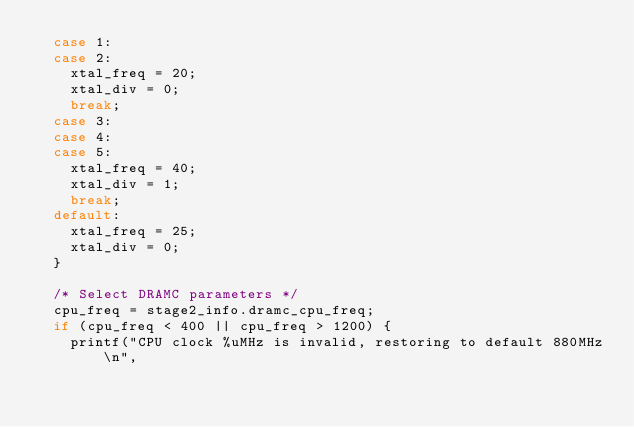<code> <loc_0><loc_0><loc_500><loc_500><_C_>	case 1:
	case 2:
		xtal_freq = 20;
		xtal_div = 0;
		break;
	case 3:
	case 4:
	case 5:
		xtal_freq = 40;
		xtal_div = 1;
		break;
	default:
		xtal_freq = 25;
		xtal_div = 0;
	}

	/* Select DRAMC parameters */
	cpu_freq = stage2_info.dramc_cpu_freq;
	if (cpu_freq < 400 || cpu_freq > 1200) {
		printf("CPU clock %uMHz is invalid, restoring to default 880MHz\n",</code> 